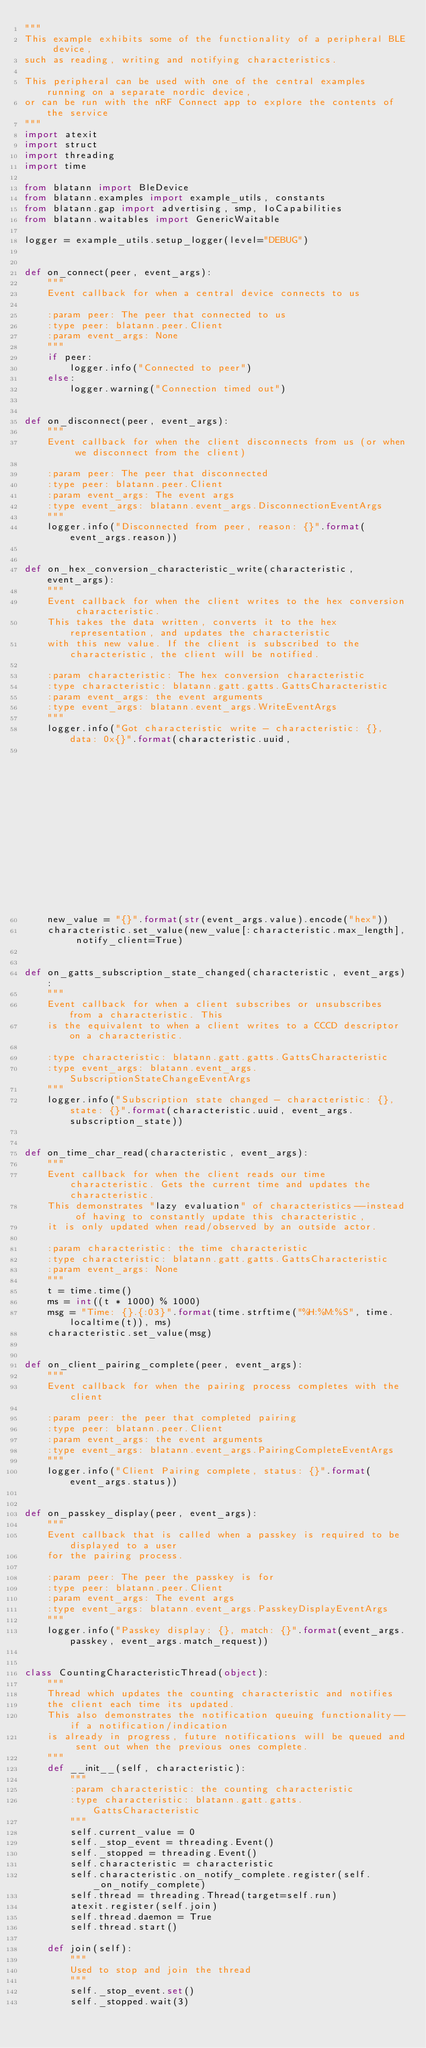Convert code to text. <code><loc_0><loc_0><loc_500><loc_500><_Python_>"""
This example exhibits some of the functionality of a peripheral BLE device,
such as reading, writing and notifying characteristics.

This peripheral can be used with one of the central examples running on a separate nordic device,
or can be run with the nRF Connect app to explore the contents of the service
"""
import atexit
import struct
import threading
import time

from blatann import BleDevice
from blatann.examples import example_utils, constants
from blatann.gap import advertising, smp, IoCapabilities
from blatann.waitables import GenericWaitable

logger = example_utils.setup_logger(level="DEBUG")


def on_connect(peer, event_args):
    """
    Event callback for when a central device connects to us

    :param peer: The peer that connected to us
    :type peer: blatann.peer.Client
    :param event_args: None
    """
    if peer:
        logger.info("Connected to peer")
    else:
        logger.warning("Connection timed out")


def on_disconnect(peer, event_args):
    """
    Event callback for when the client disconnects from us (or when we disconnect from the client)

    :param peer: The peer that disconnected
    :type peer: blatann.peer.Client
    :param event_args: The event args
    :type event_args: blatann.event_args.DisconnectionEventArgs
    """
    logger.info("Disconnected from peer, reason: {}".format(event_args.reason))


def on_hex_conversion_characteristic_write(characteristic, event_args):
    """
    Event callback for when the client writes to the hex conversion characteristic.
    This takes the data written, converts it to the hex representation, and updates the characteristic
    with this new value. If the client is subscribed to the characteristic, the client will be notified.

    :param characteristic: The hex conversion characteristic
    :type characteristic: blatann.gatt.gatts.GattsCharacteristic
    :param event_args: the event arguments
    :type event_args: blatann.event_args.WriteEventArgs
    """
    logger.info("Got characteristic write - characteristic: {}, data: 0x{}".format(characteristic.uuid,
                                                                                   str(event_args.value).encode("hex")))
    new_value = "{}".format(str(event_args.value).encode("hex"))
    characteristic.set_value(new_value[:characteristic.max_length], notify_client=True)


def on_gatts_subscription_state_changed(characteristic, event_args):
    """
    Event callback for when a client subscribes or unsubscribes from a characteristic. This
    is the equivalent to when a client writes to a CCCD descriptor on a characteristic.

    :type characteristic: blatann.gatt.gatts.GattsCharacteristic
    :type event_args: blatann.event_args.SubscriptionStateChangeEventArgs
    """
    logger.info("Subscription state changed - characteristic: {}, state: {}".format(characteristic.uuid, event_args.subscription_state))


def on_time_char_read(characteristic, event_args):
    """
    Event callback for when the client reads our time characteristic. Gets the current time and updates the characteristic.
    This demonstrates "lazy evaluation" of characteristics--instead of having to constantly update this characteristic,
    it is only updated when read/observed by an outside actor.

    :param characteristic: the time characteristic
    :type characteristic: blatann.gatt.gatts.GattsCharacteristic
    :param event_args: None
    """
    t = time.time()
    ms = int((t * 1000) % 1000)
    msg = "Time: {}.{:03}".format(time.strftime("%H:%M:%S", time.localtime(t)), ms)
    characteristic.set_value(msg)


def on_client_pairing_complete(peer, event_args):
    """
    Event callback for when the pairing process completes with the client

    :param peer: the peer that completed pairing
    :type peer: blatann.peer.Client
    :param event_args: the event arguments
    :type event_args: blatann.event_args.PairingCompleteEventArgs
    """
    logger.info("Client Pairing complete, status: {}".format(event_args.status))


def on_passkey_display(peer, event_args):
    """
    Event callback that is called when a passkey is required to be displayed to a user
    for the pairing process.

    :param peer: The peer the passkey is for
    :type peer: blatann.peer.Client
    :param event_args: The event args
    :type event_args: blatann.event_args.PasskeyDisplayEventArgs
    """
    logger.info("Passkey display: {}, match: {}".format(event_args.passkey, event_args.match_request))


class CountingCharacteristicThread(object):
    """
    Thread which updates the counting characteristic and notifies
    the client each time its updated.
    This also demonstrates the notification queuing functionality--if a notification/indication
    is already in progress, future notifications will be queued and sent out when the previous ones complete.
    """
    def __init__(self, characteristic):
        """
        :param characteristic: the counting characteristic
        :type characteristic: blatann.gatt.gatts.GattsCharacteristic
        """
        self.current_value = 0
        self._stop_event = threading.Event()
        self._stopped = threading.Event()
        self.characteristic = characteristic
        self.characteristic.on_notify_complete.register(self._on_notify_complete)
        self.thread = threading.Thread(target=self.run)
        atexit.register(self.join)
        self.thread.daemon = True
        self.thread.start()

    def join(self):
        """
        Used to stop and join the thread
        """
        self._stop_event.set()
        self._stopped.wait(3)
</code> 